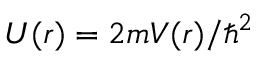<formula> <loc_0><loc_0><loc_500><loc_500>U ( r ) = 2 m V ( r ) / \hbar { ^ } { 2 }</formula> 